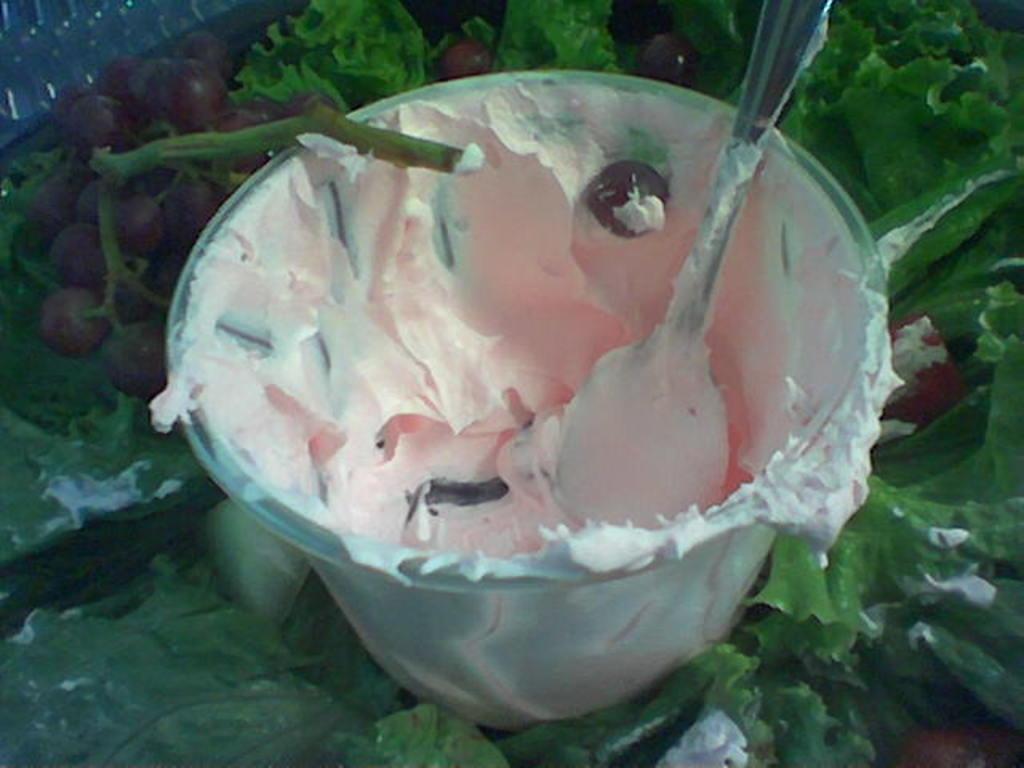Could you give a brief overview of what you see in this image? Here in this picture we can see ice cream present in a cup and we can also see a spoon in it and beside that we can see grapes and some leaves present over there. 